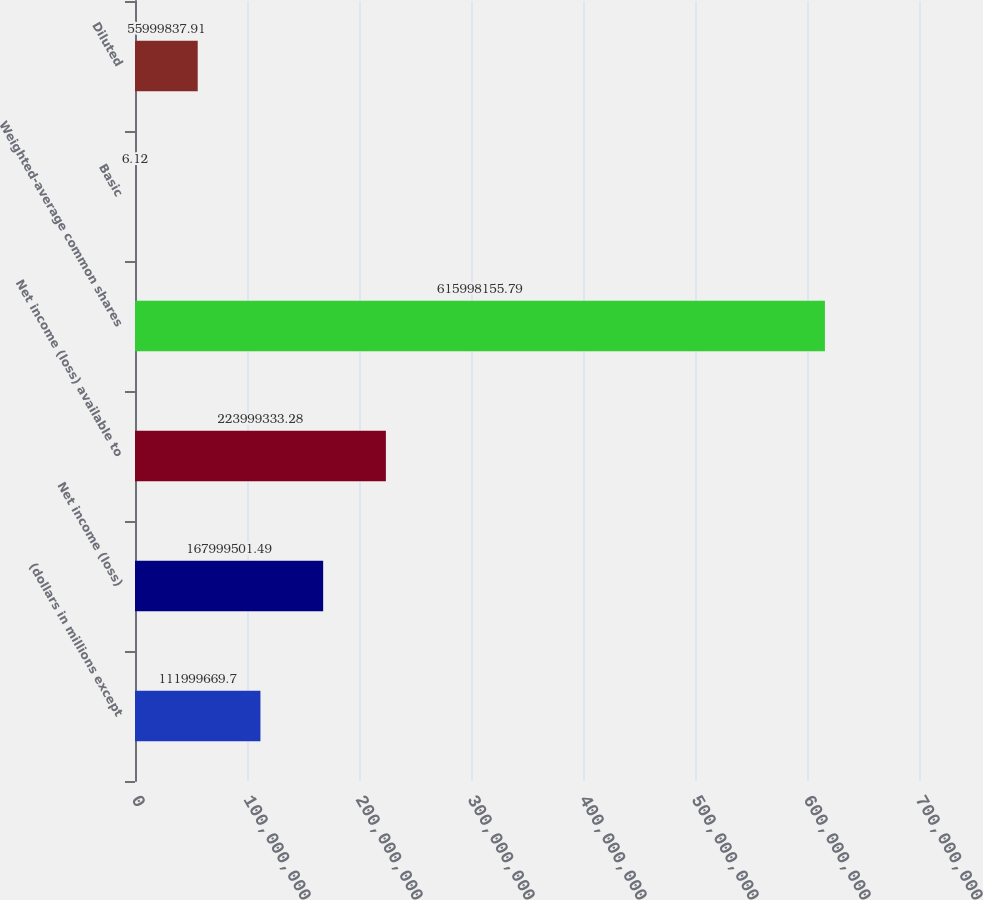<chart> <loc_0><loc_0><loc_500><loc_500><bar_chart><fcel>(dollars in millions except<fcel>Net income (loss)<fcel>Net income (loss) available to<fcel>Weighted-average common shares<fcel>Basic<fcel>Diluted<nl><fcel>1.12e+08<fcel>1.68e+08<fcel>2.23999e+08<fcel>6.15998e+08<fcel>6.12<fcel>5.59998e+07<nl></chart> 